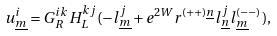<formula> <loc_0><loc_0><loc_500><loc_500>u _ { \underline { m } } ^ { i } = G _ { R } ^ { i k } H _ { L } ^ { k j } ( - l _ { \underline { m } } ^ { j } + e ^ { 2 W } r ^ { ( + + ) \underline { n } } l _ { \underline { n } } ^ { j } l _ { \underline { m } } ^ { ( - - ) } ) ,</formula> 